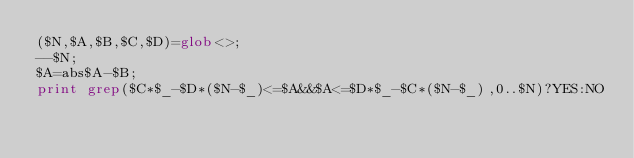Convert code to text. <code><loc_0><loc_0><loc_500><loc_500><_Perl_>($N,$A,$B,$C,$D)=glob<>;
--$N;
$A=abs$A-$B;
print grep($C*$_-$D*($N-$_)<=$A&&$A<=$D*$_-$C*($N-$_),0..$N)?YES:NO
</code> 